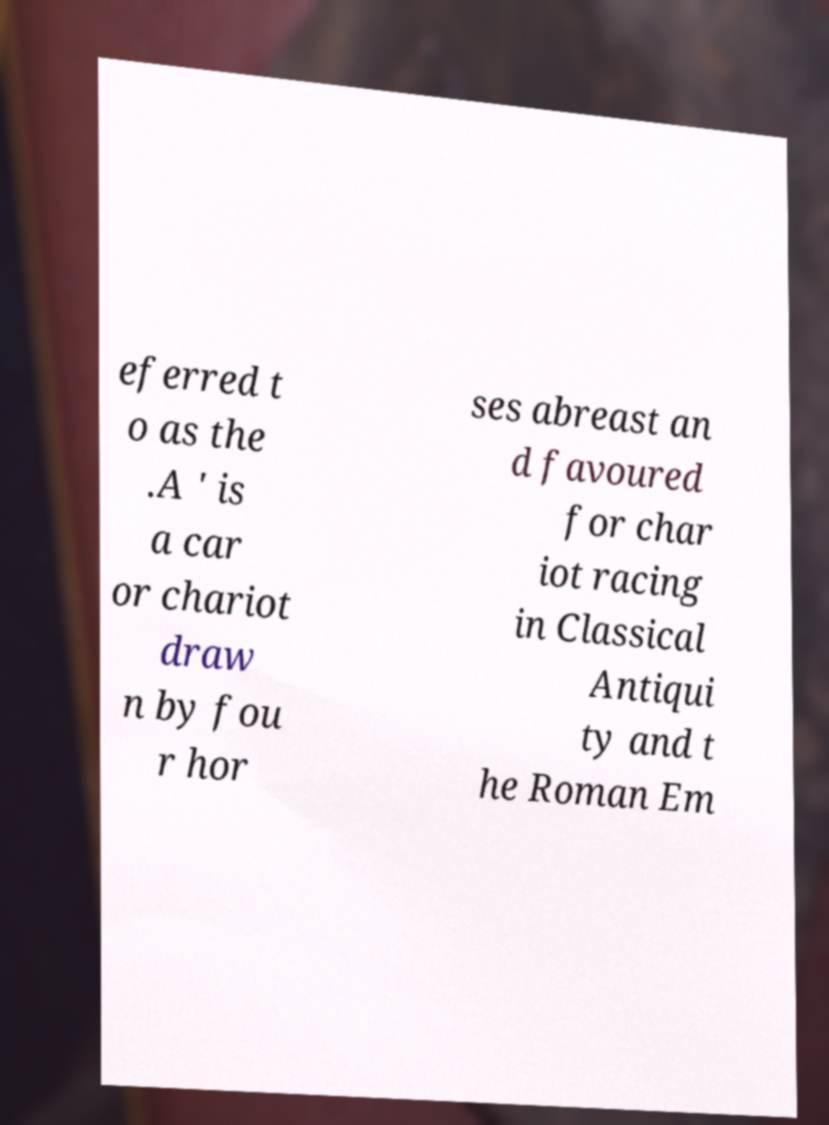Can you accurately transcribe the text from the provided image for me? eferred t o as the .A ' is a car or chariot draw n by fou r hor ses abreast an d favoured for char iot racing in Classical Antiqui ty and t he Roman Em 